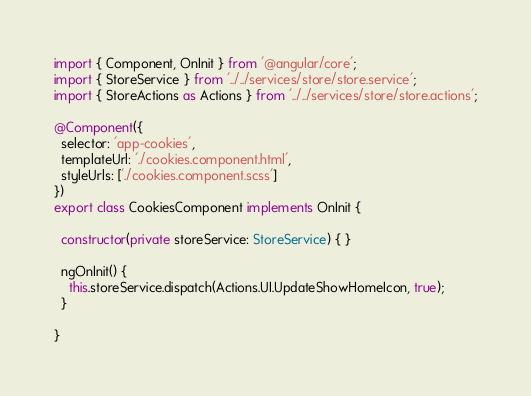Convert code to text. <code><loc_0><loc_0><loc_500><loc_500><_TypeScript_>import { Component, OnInit } from '@angular/core';
import { StoreService } from '../../services/store/store.service';
import { StoreActions as Actions } from '../../services/store/store.actions';

@Component({
  selector: 'app-cookies',
  templateUrl: './cookies.component.html',
  styleUrls: ['./cookies.component.scss']
})
export class CookiesComponent implements OnInit {

  constructor(private storeService: StoreService) { }

  ngOnInit() {
    this.storeService.dispatch(Actions.UI.UpdateShowHomeIcon, true);
  }

}
</code> 